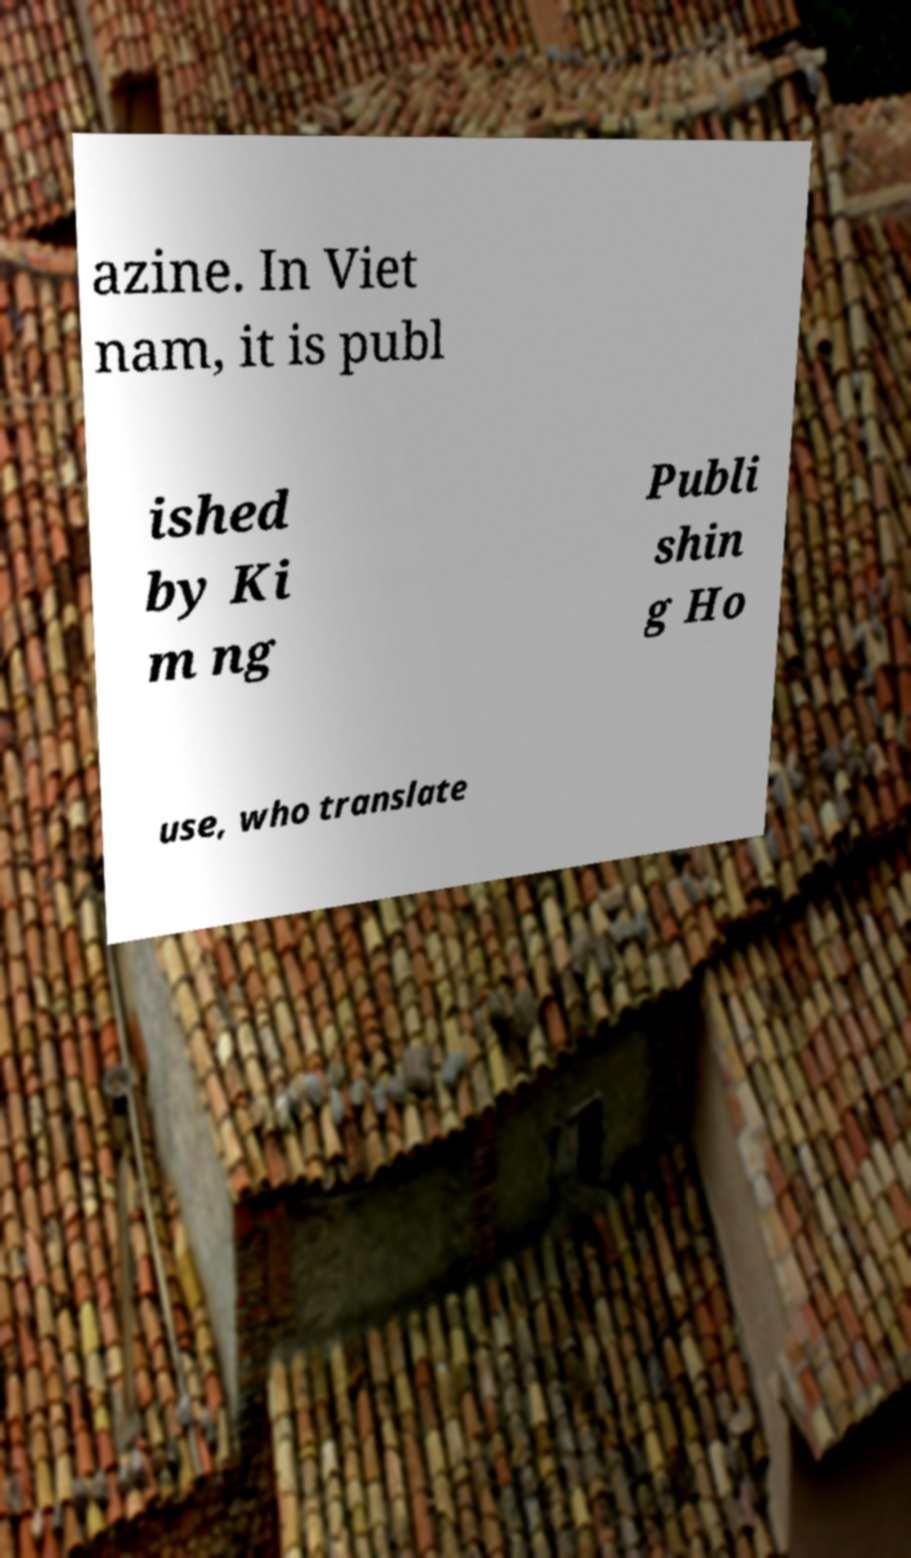Could you assist in decoding the text presented in this image and type it out clearly? azine. In Viet nam, it is publ ished by Ki m ng Publi shin g Ho use, who translate 